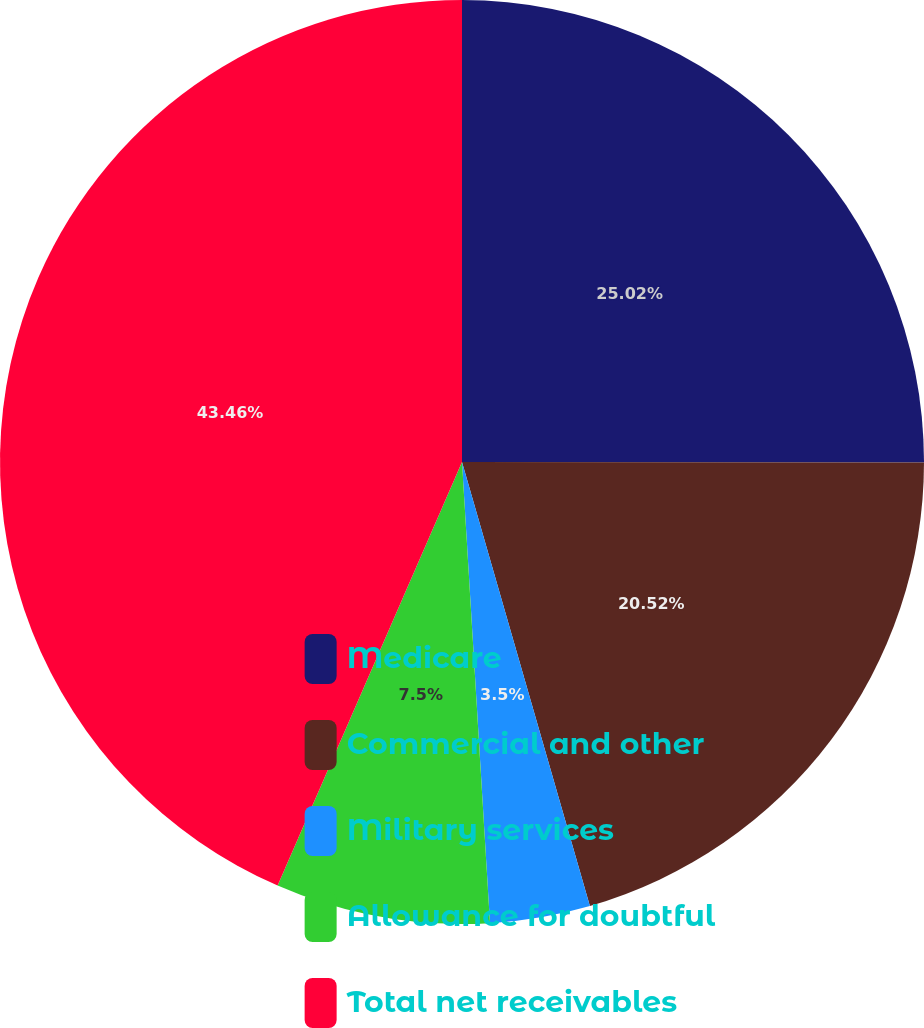Convert chart. <chart><loc_0><loc_0><loc_500><loc_500><pie_chart><fcel>Medicare<fcel>Commercial and other<fcel>Military services<fcel>Allowance for doubtful<fcel>Total net receivables<nl><fcel>25.02%<fcel>20.52%<fcel>3.5%<fcel>7.5%<fcel>43.47%<nl></chart> 